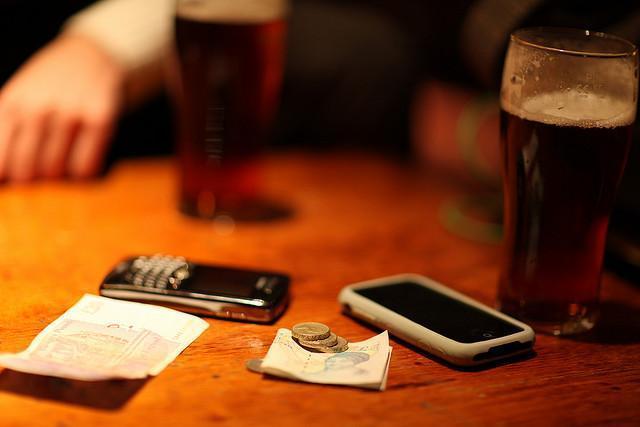How many people can be seen?
Give a very brief answer. 1. How many cups are there?
Give a very brief answer. 2. How many cell phones can you see?
Give a very brief answer. 2. 